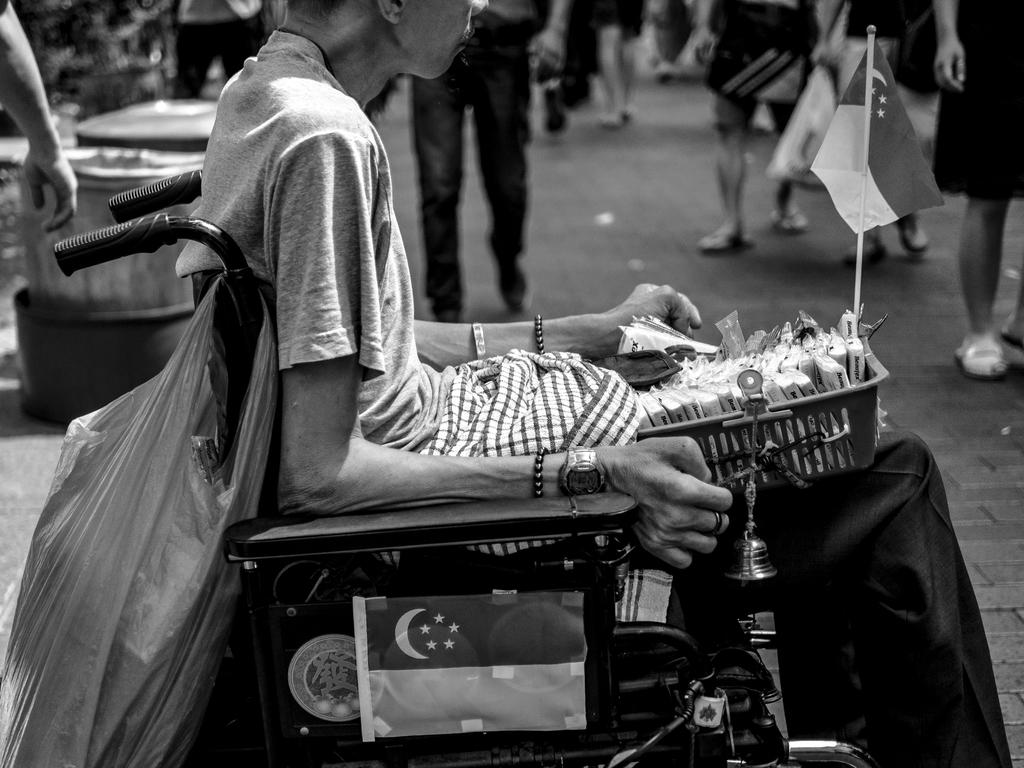What is the woman in the image doing? The woman is seated on a wheelchair in the image. What is the woman holding in the image? The woman is holding a basket in the image. What else is attached to the basket? There is a flag attached to the basket. What can be seen hanging from the wheelchair? A carry bag is hanging from the wheelchair. What is happening in the background of the image? There are people walking in the image. What flavor of ice cream is the woman eating in the image? There is no ice cream present in the image, so it is not possible to determine the flavor. 